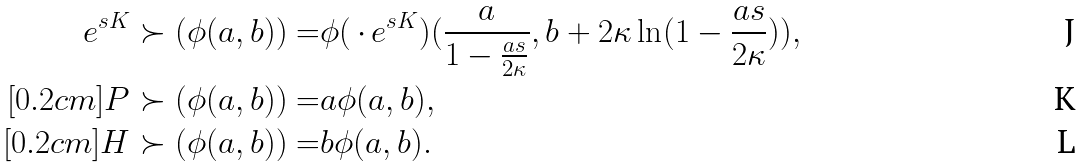Convert formula to latex. <formula><loc_0><loc_0><loc_500><loc_500>e ^ { s K } \succ ( \phi ( a , b ) ) = & \phi ( \, \cdot \, e ^ { s K } ) ( \frac { a } { 1 - \frac { a s } { 2 \kappa } } , b + 2 \kappa \ln ( 1 - \frac { a s } { 2 \kappa } ) ) , \\ [ 0 . 2 c m ] P \succ ( \phi ( a , b ) ) = & a \phi ( a , b ) , \\ [ 0 . 2 c m ] H \succ ( \phi ( a , b ) ) = & b \phi ( a , b ) .</formula> 